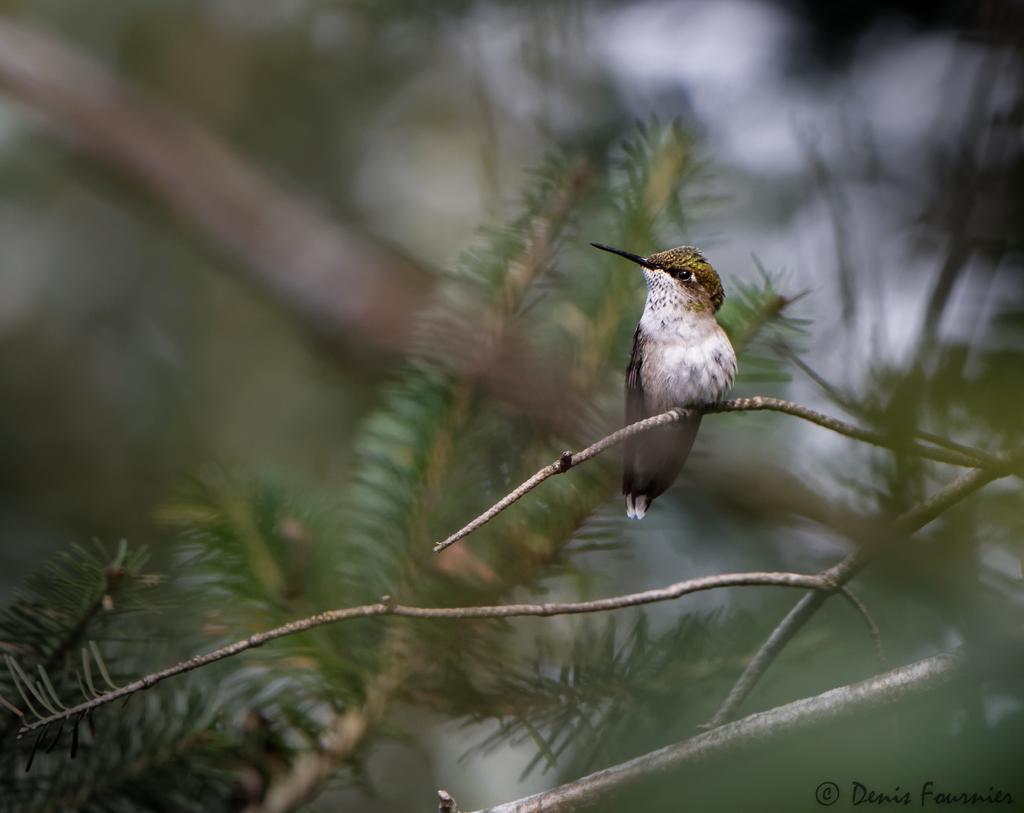Describe this image in one or two sentences. In the image there is a bird standing on branch of a tree. 